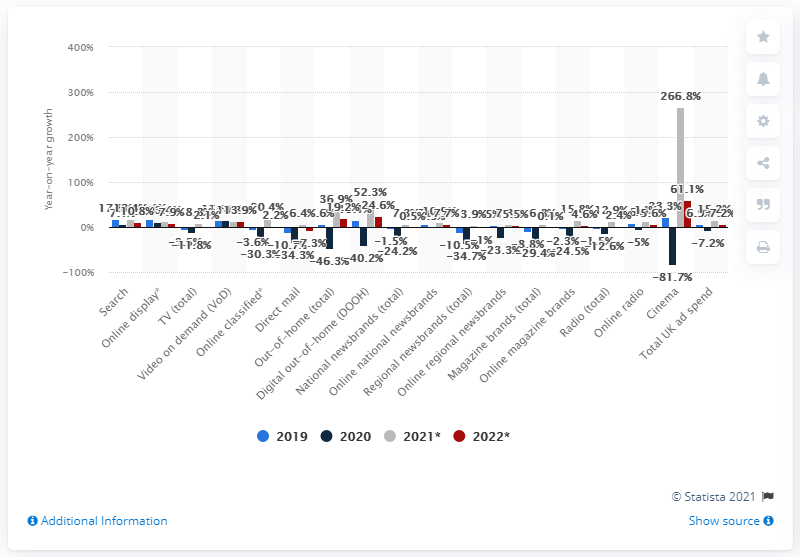Give some essential details in this illustration. According to projections, digital out-of-home is expected to increase by 52.3% in 2021. By the end of 2021, online classifieds ad spend is projected to increase by 20.4%. 